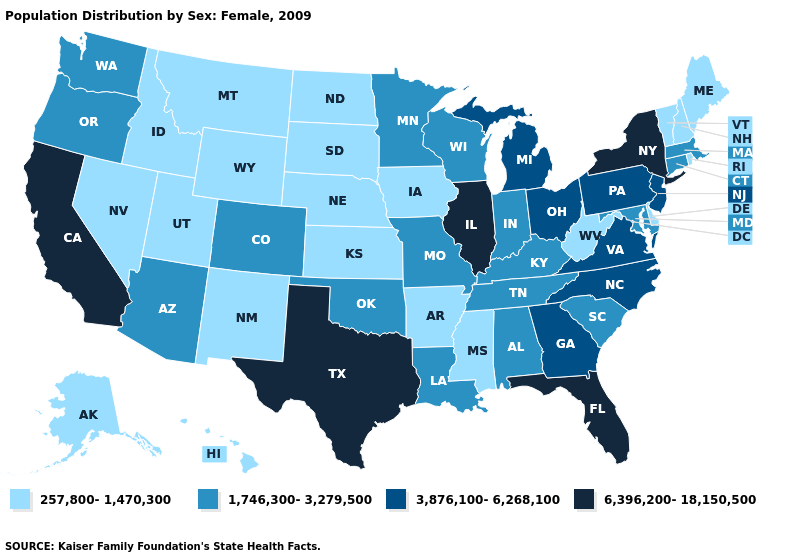How many symbols are there in the legend?
Be succinct. 4. Name the states that have a value in the range 6,396,200-18,150,500?
Concise answer only. California, Florida, Illinois, New York, Texas. What is the highest value in the South ?
Give a very brief answer. 6,396,200-18,150,500. Name the states that have a value in the range 257,800-1,470,300?
Short answer required. Alaska, Arkansas, Delaware, Hawaii, Idaho, Iowa, Kansas, Maine, Mississippi, Montana, Nebraska, Nevada, New Hampshire, New Mexico, North Dakota, Rhode Island, South Dakota, Utah, Vermont, West Virginia, Wyoming. What is the value of Florida?
Answer briefly. 6,396,200-18,150,500. What is the highest value in the Northeast ?
Keep it brief. 6,396,200-18,150,500. Does New York have the highest value in the Northeast?
Be succinct. Yes. Does South Carolina have the lowest value in the USA?
Short answer required. No. Does Wisconsin have the lowest value in the USA?
Short answer required. No. How many symbols are there in the legend?
Quick response, please. 4. What is the value of Wisconsin?
Be succinct. 1,746,300-3,279,500. What is the highest value in the USA?
Keep it brief. 6,396,200-18,150,500. Does New Hampshire have the highest value in the USA?
Quick response, please. No. Name the states that have a value in the range 3,876,100-6,268,100?
Answer briefly. Georgia, Michigan, New Jersey, North Carolina, Ohio, Pennsylvania, Virginia. What is the value of Kansas?
Short answer required. 257,800-1,470,300. 